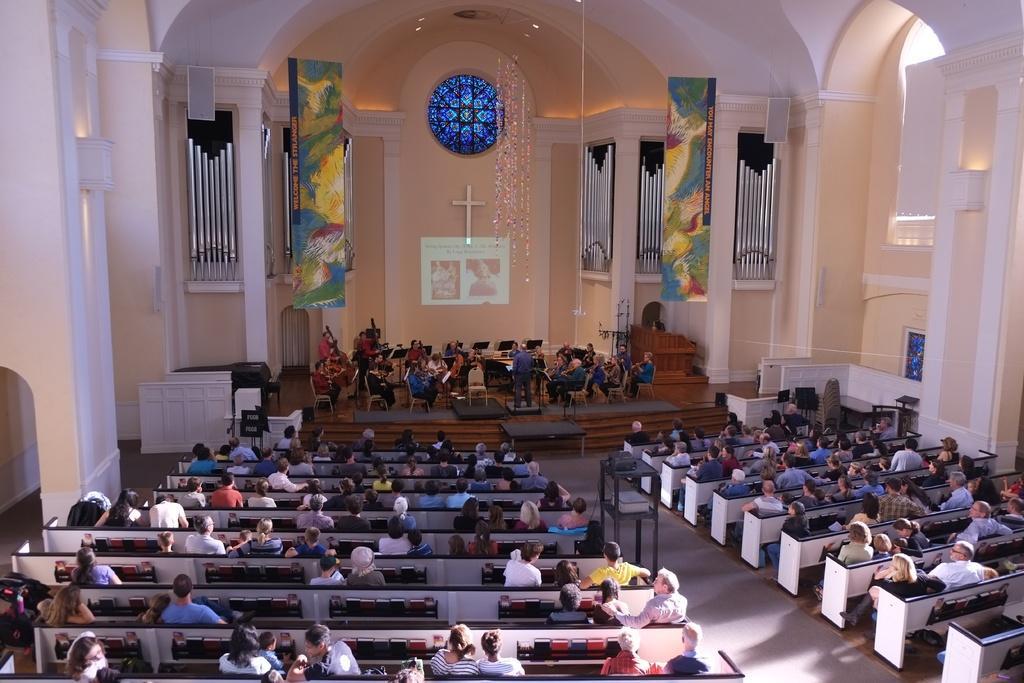Please provide a concise description of this image. In this picture I can see there are many people sitting on the benches and there are few other people sitting on the chairs, at the dais and there are few lights attached to the ceiling. 